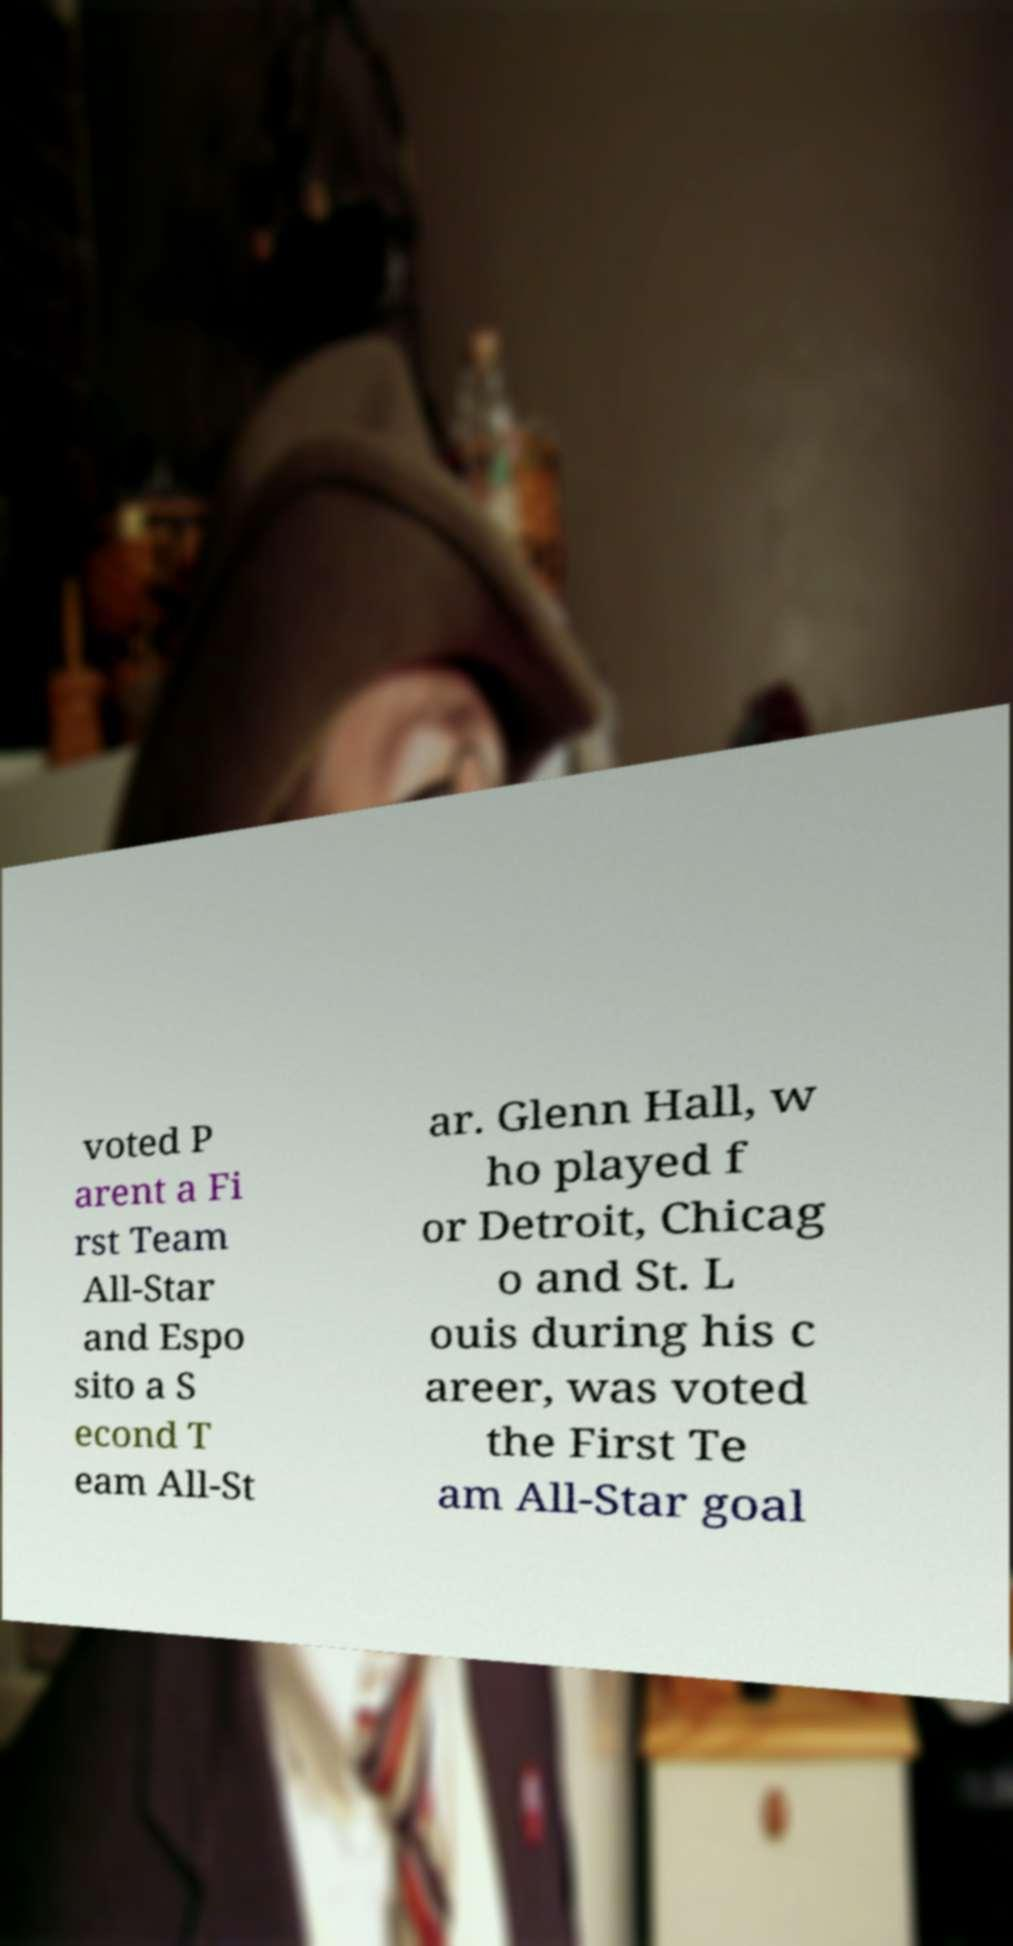For documentation purposes, I need the text within this image transcribed. Could you provide that? voted P arent a Fi rst Team All-Star and Espo sito a S econd T eam All-St ar. Glenn Hall, w ho played f or Detroit, Chicag o and St. L ouis during his c areer, was voted the First Te am All-Star goal 